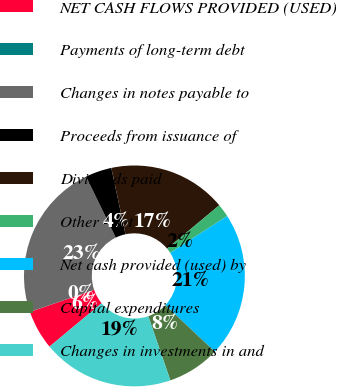<chart> <loc_0><loc_0><loc_500><loc_500><pie_chart><fcel>NET CASH FLOWS PROVIDED (USED)<fcel>Payments of long-term debt<fcel>Changes in notes payable to<fcel>Proceeds from issuance of<fcel>Dividends paid<fcel>Other - net<fcel>Net cash provided (used) by<fcel>Capital expenditures<fcel>Changes in investments in and<nl><fcel>5.77%<fcel>0.01%<fcel>23.07%<fcel>3.85%<fcel>17.3%<fcel>1.93%<fcel>21.14%<fcel>7.7%<fcel>19.22%<nl></chart> 